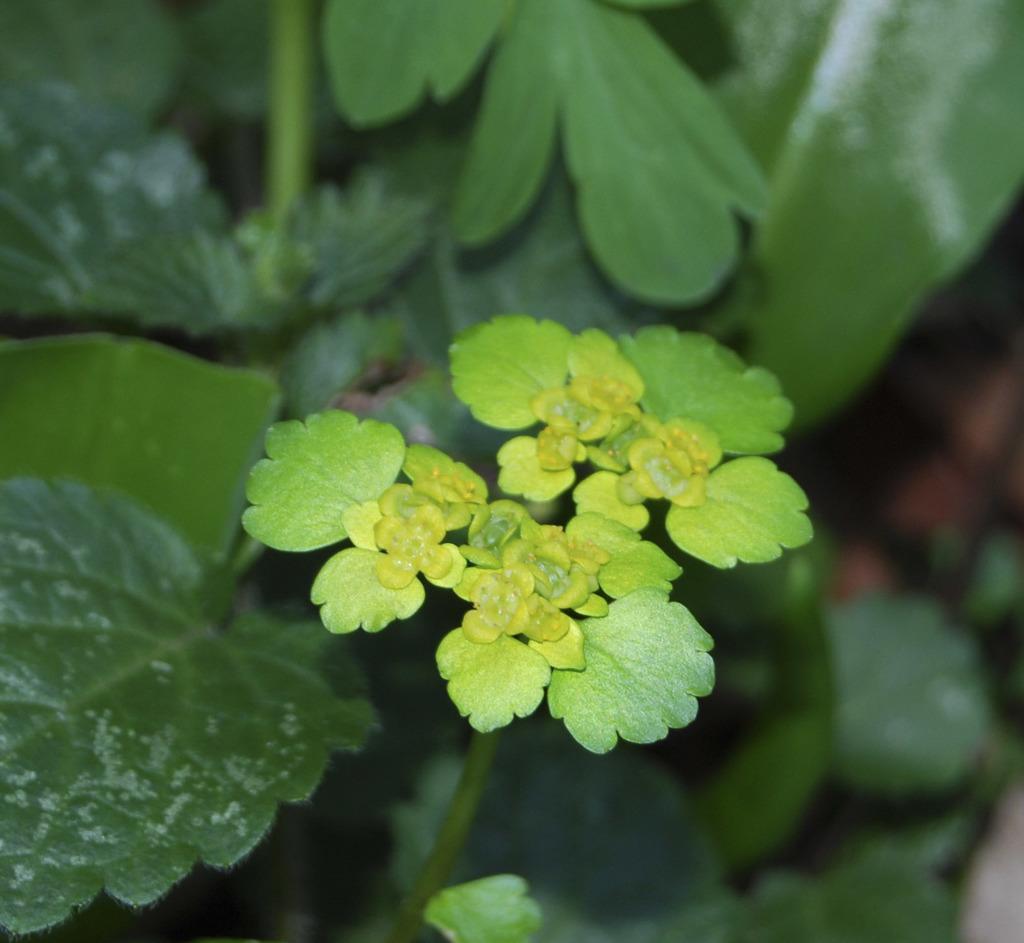Can you describe this image briefly? In this picture i can see the plants. In the center can see many leaves. 